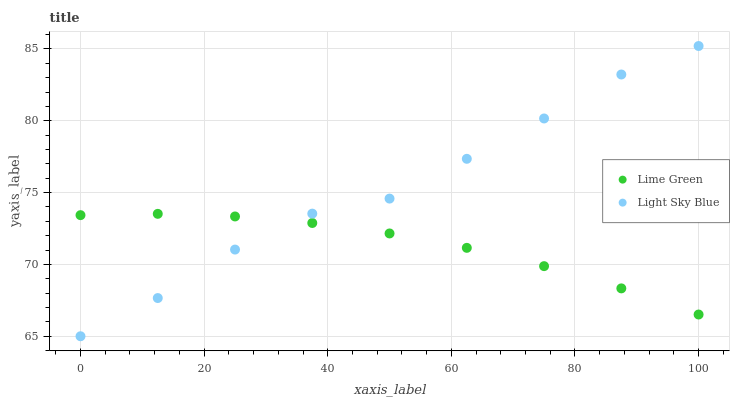Does Lime Green have the minimum area under the curve?
Answer yes or no. Yes. Does Light Sky Blue have the maximum area under the curve?
Answer yes or no. Yes. Does Lime Green have the maximum area under the curve?
Answer yes or no. No. Is Lime Green the smoothest?
Answer yes or no. Yes. Is Light Sky Blue the roughest?
Answer yes or no. Yes. Is Lime Green the roughest?
Answer yes or no. No. Does Light Sky Blue have the lowest value?
Answer yes or no. Yes. Does Lime Green have the lowest value?
Answer yes or no. No. Does Light Sky Blue have the highest value?
Answer yes or no. Yes. Does Lime Green have the highest value?
Answer yes or no. No. Does Lime Green intersect Light Sky Blue?
Answer yes or no. Yes. Is Lime Green less than Light Sky Blue?
Answer yes or no. No. Is Lime Green greater than Light Sky Blue?
Answer yes or no. No. 